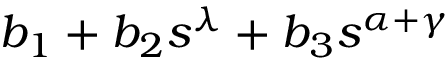Convert formula to latex. <formula><loc_0><loc_0><loc_500><loc_500>b _ { 1 } + b _ { 2 } s ^ { \lambda } + b _ { 3 } s ^ { \alpha + \gamma }</formula> 